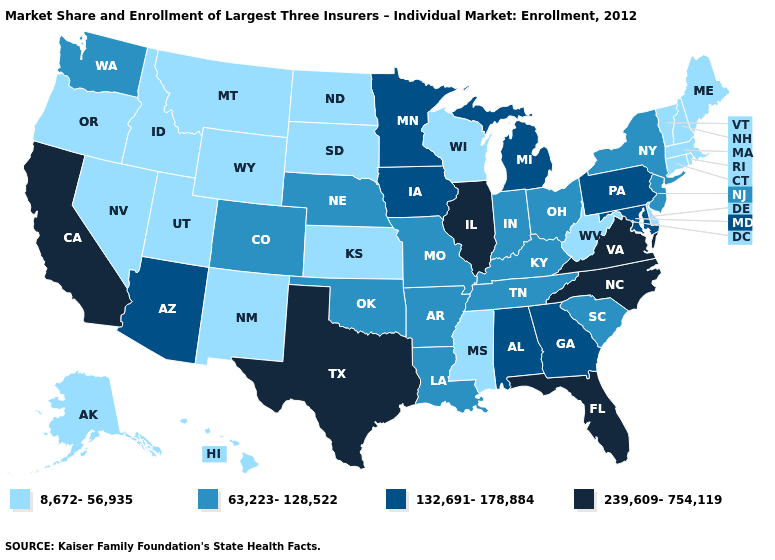What is the value of North Carolina?
Concise answer only. 239,609-754,119. Does Texas have the lowest value in the USA?
Be succinct. No. Among the states that border Massachusetts , which have the lowest value?
Answer briefly. Connecticut, New Hampshire, Rhode Island, Vermont. Name the states that have a value in the range 239,609-754,119?
Short answer required. California, Florida, Illinois, North Carolina, Texas, Virginia. What is the value of Hawaii?
Concise answer only. 8,672-56,935. Does the map have missing data?
Concise answer only. No. Name the states that have a value in the range 239,609-754,119?
Be succinct. California, Florida, Illinois, North Carolina, Texas, Virginia. What is the value of Connecticut?
Write a very short answer. 8,672-56,935. What is the lowest value in the MidWest?
Quick response, please. 8,672-56,935. What is the lowest value in the Northeast?
Short answer required. 8,672-56,935. What is the value of Nevada?
Answer briefly. 8,672-56,935. What is the lowest value in the USA?
Answer briefly. 8,672-56,935. What is the value of Vermont?
Concise answer only. 8,672-56,935. Does Louisiana have the same value as Utah?
Write a very short answer. No. What is the value of West Virginia?
Be succinct. 8,672-56,935. 